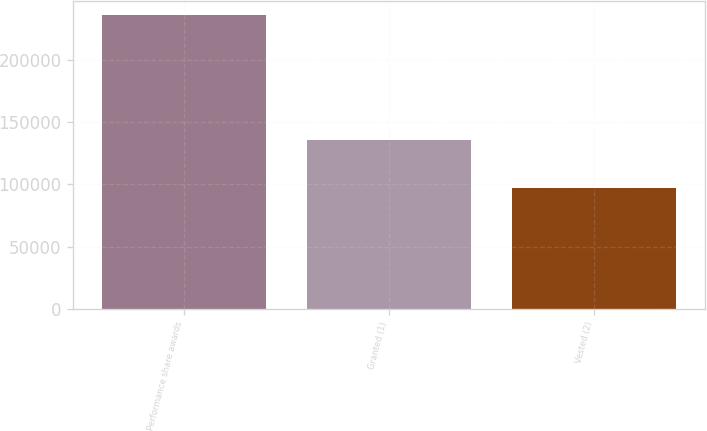<chart> <loc_0><loc_0><loc_500><loc_500><bar_chart><fcel>Performance share awards<fcel>Granted (1)<fcel>Vested (2)<nl><fcel>235950<fcel>135780<fcel>97079<nl></chart> 